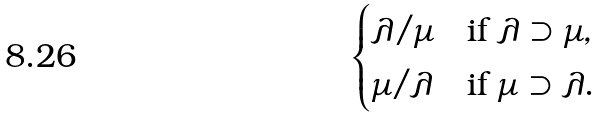Convert formula to latex. <formula><loc_0><loc_0><loc_500><loc_500>\begin{cases} \lambda / \mu & \text {if } \lambda \supset \mu , \\ \mu / \lambda & \text {if } \mu \supset \lambda . \end{cases}</formula> 